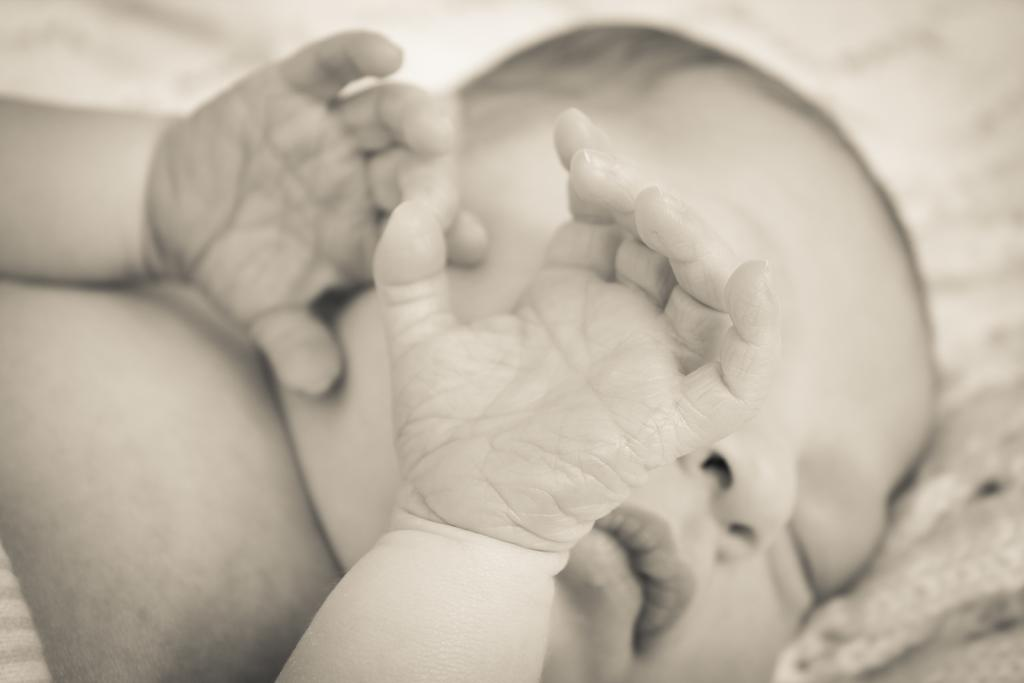What is the main subject of the image? There is a newborn baby in the image. What is the baby doing in the image? The baby is sleeping. What type of respect is the baby showing towards the minister in the image? There is no minister present in the image, and therefore no interaction between the baby and a minister can be observed. What brand of toothpaste is the baby using in the image? There is no toothpaste present in the image, and the baby is sleeping, so it is not using any toothpaste. 